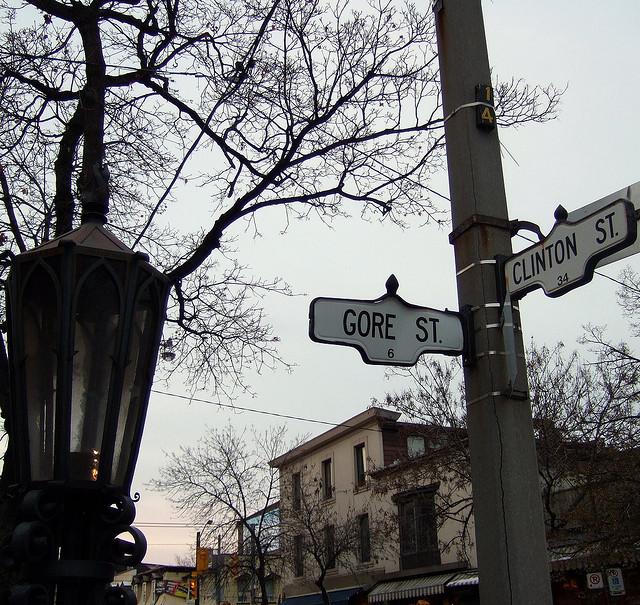What color are the street signs?
Write a very short answer. White. IS this a residential area?
Answer briefly. Yes. What street is this?
Answer briefly. Gore. 